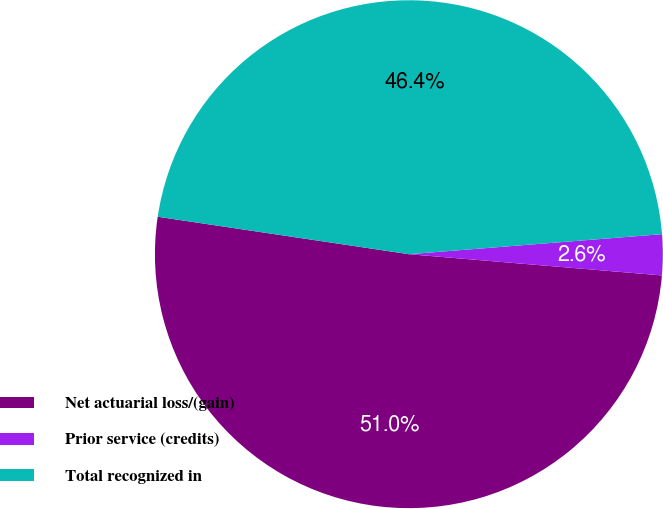<chart> <loc_0><loc_0><loc_500><loc_500><pie_chart><fcel>Net actuarial loss/(gain)<fcel>Prior service (credits)<fcel>Total recognized in<nl><fcel>51.03%<fcel>2.59%<fcel>46.39%<nl></chart> 